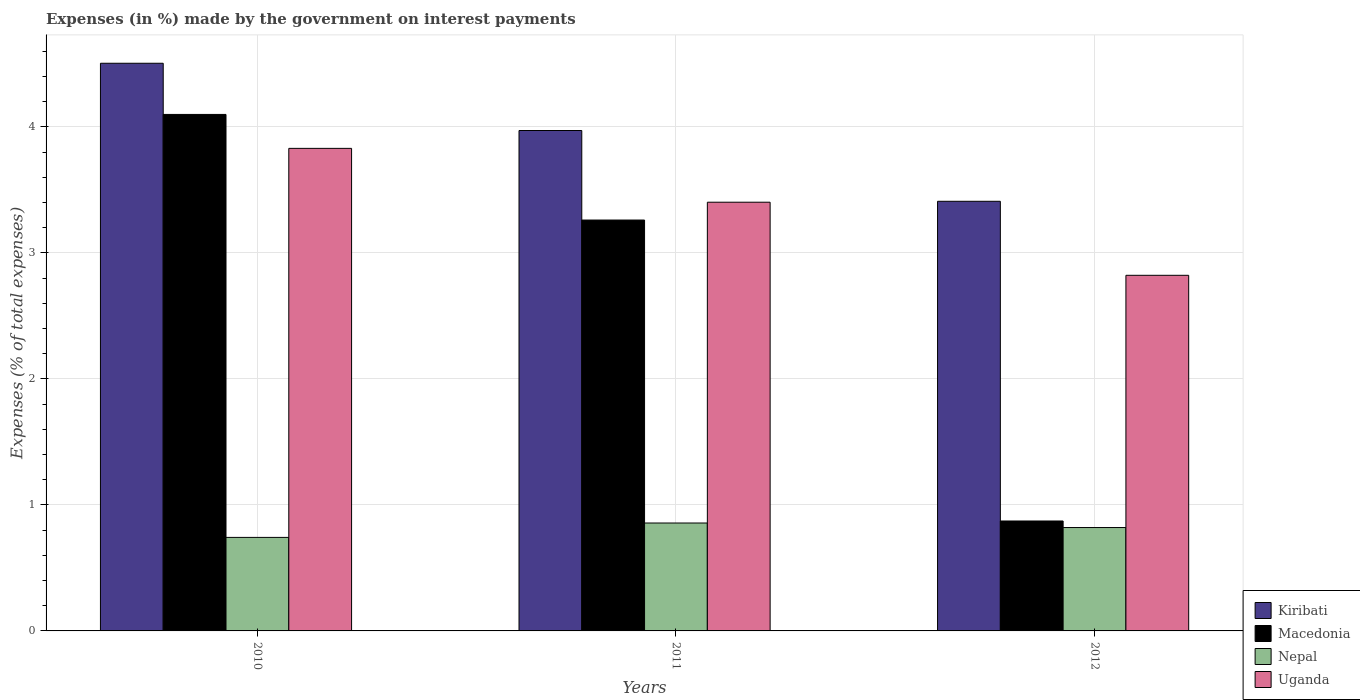How many groups of bars are there?
Offer a very short reply. 3. Are the number of bars per tick equal to the number of legend labels?
Your response must be concise. Yes. How many bars are there on the 1st tick from the left?
Make the answer very short. 4. What is the label of the 3rd group of bars from the left?
Keep it short and to the point. 2012. What is the percentage of expenses made by the government on interest payments in Uganda in 2011?
Ensure brevity in your answer.  3.4. Across all years, what is the maximum percentage of expenses made by the government on interest payments in Uganda?
Ensure brevity in your answer.  3.83. Across all years, what is the minimum percentage of expenses made by the government on interest payments in Macedonia?
Ensure brevity in your answer.  0.87. In which year was the percentage of expenses made by the government on interest payments in Uganda maximum?
Provide a short and direct response. 2010. What is the total percentage of expenses made by the government on interest payments in Nepal in the graph?
Your answer should be compact. 2.42. What is the difference between the percentage of expenses made by the government on interest payments in Kiribati in 2010 and that in 2012?
Offer a very short reply. 1.1. What is the difference between the percentage of expenses made by the government on interest payments in Uganda in 2011 and the percentage of expenses made by the government on interest payments in Nepal in 2010?
Provide a short and direct response. 2.66. What is the average percentage of expenses made by the government on interest payments in Macedonia per year?
Your response must be concise. 2.74. In the year 2011, what is the difference between the percentage of expenses made by the government on interest payments in Kiribati and percentage of expenses made by the government on interest payments in Macedonia?
Make the answer very short. 0.71. In how many years, is the percentage of expenses made by the government on interest payments in Kiribati greater than 3.2 %?
Provide a succinct answer. 3. What is the ratio of the percentage of expenses made by the government on interest payments in Kiribati in 2010 to that in 2012?
Give a very brief answer. 1.32. What is the difference between the highest and the second highest percentage of expenses made by the government on interest payments in Kiribati?
Your answer should be very brief. 0.53. What is the difference between the highest and the lowest percentage of expenses made by the government on interest payments in Macedonia?
Offer a very short reply. 3.23. What does the 4th bar from the left in 2011 represents?
Provide a short and direct response. Uganda. What does the 3rd bar from the right in 2012 represents?
Offer a very short reply. Macedonia. How many bars are there?
Provide a short and direct response. 12. What is the difference between two consecutive major ticks on the Y-axis?
Provide a short and direct response. 1. Are the values on the major ticks of Y-axis written in scientific E-notation?
Offer a very short reply. No. Where does the legend appear in the graph?
Provide a succinct answer. Bottom right. How are the legend labels stacked?
Keep it short and to the point. Vertical. What is the title of the graph?
Provide a succinct answer. Expenses (in %) made by the government on interest payments. What is the label or title of the X-axis?
Offer a very short reply. Years. What is the label or title of the Y-axis?
Give a very brief answer. Expenses (% of total expenses). What is the Expenses (% of total expenses) in Kiribati in 2010?
Give a very brief answer. 4.51. What is the Expenses (% of total expenses) of Macedonia in 2010?
Your answer should be compact. 4.1. What is the Expenses (% of total expenses) in Nepal in 2010?
Provide a short and direct response. 0.74. What is the Expenses (% of total expenses) in Uganda in 2010?
Your answer should be very brief. 3.83. What is the Expenses (% of total expenses) in Kiribati in 2011?
Provide a short and direct response. 3.97. What is the Expenses (% of total expenses) in Macedonia in 2011?
Keep it short and to the point. 3.26. What is the Expenses (% of total expenses) in Nepal in 2011?
Ensure brevity in your answer.  0.86. What is the Expenses (% of total expenses) in Uganda in 2011?
Your answer should be very brief. 3.4. What is the Expenses (% of total expenses) of Kiribati in 2012?
Keep it short and to the point. 3.41. What is the Expenses (% of total expenses) in Macedonia in 2012?
Your answer should be very brief. 0.87. What is the Expenses (% of total expenses) in Nepal in 2012?
Provide a succinct answer. 0.82. What is the Expenses (% of total expenses) of Uganda in 2012?
Give a very brief answer. 2.82. Across all years, what is the maximum Expenses (% of total expenses) in Kiribati?
Provide a succinct answer. 4.51. Across all years, what is the maximum Expenses (% of total expenses) in Macedonia?
Give a very brief answer. 4.1. Across all years, what is the maximum Expenses (% of total expenses) of Nepal?
Offer a terse response. 0.86. Across all years, what is the maximum Expenses (% of total expenses) in Uganda?
Make the answer very short. 3.83. Across all years, what is the minimum Expenses (% of total expenses) of Kiribati?
Make the answer very short. 3.41. Across all years, what is the minimum Expenses (% of total expenses) in Macedonia?
Offer a very short reply. 0.87. Across all years, what is the minimum Expenses (% of total expenses) in Nepal?
Your answer should be very brief. 0.74. Across all years, what is the minimum Expenses (% of total expenses) in Uganda?
Provide a short and direct response. 2.82. What is the total Expenses (% of total expenses) of Kiribati in the graph?
Ensure brevity in your answer.  11.89. What is the total Expenses (% of total expenses) in Macedonia in the graph?
Offer a very short reply. 8.23. What is the total Expenses (% of total expenses) in Nepal in the graph?
Keep it short and to the point. 2.42. What is the total Expenses (% of total expenses) in Uganda in the graph?
Your answer should be very brief. 10.05. What is the difference between the Expenses (% of total expenses) of Kiribati in 2010 and that in 2011?
Provide a succinct answer. 0.53. What is the difference between the Expenses (% of total expenses) of Macedonia in 2010 and that in 2011?
Your response must be concise. 0.84. What is the difference between the Expenses (% of total expenses) in Nepal in 2010 and that in 2011?
Provide a succinct answer. -0.11. What is the difference between the Expenses (% of total expenses) in Uganda in 2010 and that in 2011?
Your answer should be compact. 0.43. What is the difference between the Expenses (% of total expenses) of Kiribati in 2010 and that in 2012?
Provide a short and direct response. 1.1. What is the difference between the Expenses (% of total expenses) of Macedonia in 2010 and that in 2012?
Provide a short and direct response. 3.23. What is the difference between the Expenses (% of total expenses) of Nepal in 2010 and that in 2012?
Provide a succinct answer. -0.08. What is the difference between the Expenses (% of total expenses) of Uganda in 2010 and that in 2012?
Your answer should be very brief. 1.01. What is the difference between the Expenses (% of total expenses) of Kiribati in 2011 and that in 2012?
Your answer should be compact. 0.56. What is the difference between the Expenses (% of total expenses) of Macedonia in 2011 and that in 2012?
Offer a terse response. 2.39. What is the difference between the Expenses (% of total expenses) in Nepal in 2011 and that in 2012?
Provide a short and direct response. 0.04. What is the difference between the Expenses (% of total expenses) in Uganda in 2011 and that in 2012?
Give a very brief answer. 0.58. What is the difference between the Expenses (% of total expenses) of Kiribati in 2010 and the Expenses (% of total expenses) of Macedonia in 2011?
Your answer should be compact. 1.24. What is the difference between the Expenses (% of total expenses) of Kiribati in 2010 and the Expenses (% of total expenses) of Nepal in 2011?
Provide a succinct answer. 3.65. What is the difference between the Expenses (% of total expenses) in Kiribati in 2010 and the Expenses (% of total expenses) in Uganda in 2011?
Provide a short and direct response. 1.1. What is the difference between the Expenses (% of total expenses) of Macedonia in 2010 and the Expenses (% of total expenses) of Nepal in 2011?
Make the answer very short. 3.24. What is the difference between the Expenses (% of total expenses) of Macedonia in 2010 and the Expenses (% of total expenses) of Uganda in 2011?
Make the answer very short. 0.7. What is the difference between the Expenses (% of total expenses) in Nepal in 2010 and the Expenses (% of total expenses) in Uganda in 2011?
Your answer should be compact. -2.66. What is the difference between the Expenses (% of total expenses) of Kiribati in 2010 and the Expenses (% of total expenses) of Macedonia in 2012?
Keep it short and to the point. 3.63. What is the difference between the Expenses (% of total expenses) of Kiribati in 2010 and the Expenses (% of total expenses) of Nepal in 2012?
Give a very brief answer. 3.68. What is the difference between the Expenses (% of total expenses) of Kiribati in 2010 and the Expenses (% of total expenses) of Uganda in 2012?
Ensure brevity in your answer.  1.68. What is the difference between the Expenses (% of total expenses) of Macedonia in 2010 and the Expenses (% of total expenses) of Nepal in 2012?
Keep it short and to the point. 3.28. What is the difference between the Expenses (% of total expenses) in Macedonia in 2010 and the Expenses (% of total expenses) in Uganda in 2012?
Provide a short and direct response. 1.28. What is the difference between the Expenses (% of total expenses) in Nepal in 2010 and the Expenses (% of total expenses) in Uganda in 2012?
Ensure brevity in your answer.  -2.08. What is the difference between the Expenses (% of total expenses) of Kiribati in 2011 and the Expenses (% of total expenses) of Macedonia in 2012?
Offer a terse response. 3.1. What is the difference between the Expenses (% of total expenses) in Kiribati in 2011 and the Expenses (% of total expenses) in Nepal in 2012?
Your answer should be compact. 3.15. What is the difference between the Expenses (% of total expenses) in Kiribati in 2011 and the Expenses (% of total expenses) in Uganda in 2012?
Your response must be concise. 1.15. What is the difference between the Expenses (% of total expenses) in Macedonia in 2011 and the Expenses (% of total expenses) in Nepal in 2012?
Give a very brief answer. 2.44. What is the difference between the Expenses (% of total expenses) of Macedonia in 2011 and the Expenses (% of total expenses) of Uganda in 2012?
Offer a terse response. 0.44. What is the difference between the Expenses (% of total expenses) of Nepal in 2011 and the Expenses (% of total expenses) of Uganda in 2012?
Provide a succinct answer. -1.97. What is the average Expenses (% of total expenses) in Kiribati per year?
Make the answer very short. 3.96. What is the average Expenses (% of total expenses) of Macedonia per year?
Ensure brevity in your answer.  2.74. What is the average Expenses (% of total expenses) of Nepal per year?
Your answer should be very brief. 0.81. What is the average Expenses (% of total expenses) of Uganda per year?
Your response must be concise. 3.35. In the year 2010, what is the difference between the Expenses (% of total expenses) of Kiribati and Expenses (% of total expenses) of Macedonia?
Ensure brevity in your answer.  0.41. In the year 2010, what is the difference between the Expenses (% of total expenses) of Kiribati and Expenses (% of total expenses) of Nepal?
Your response must be concise. 3.76. In the year 2010, what is the difference between the Expenses (% of total expenses) in Kiribati and Expenses (% of total expenses) in Uganda?
Your answer should be compact. 0.68. In the year 2010, what is the difference between the Expenses (% of total expenses) of Macedonia and Expenses (% of total expenses) of Nepal?
Give a very brief answer. 3.36. In the year 2010, what is the difference between the Expenses (% of total expenses) in Macedonia and Expenses (% of total expenses) in Uganda?
Your answer should be very brief. 0.27. In the year 2010, what is the difference between the Expenses (% of total expenses) of Nepal and Expenses (% of total expenses) of Uganda?
Give a very brief answer. -3.09. In the year 2011, what is the difference between the Expenses (% of total expenses) in Kiribati and Expenses (% of total expenses) in Macedonia?
Give a very brief answer. 0.71. In the year 2011, what is the difference between the Expenses (% of total expenses) of Kiribati and Expenses (% of total expenses) of Nepal?
Ensure brevity in your answer.  3.12. In the year 2011, what is the difference between the Expenses (% of total expenses) of Kiribati and Expenses (% of total expenses) of Uganda?
Offer a terse response. 0.57. In the year 2011, what is the difference between the Expenses (% of total expenses) of Macedonia and Expenses (% of total expenses) of Nepal?
Your answer should be very brief. 2.4. In the year 2011, what is the difference between the Expenses (% of total expenses) of Macedonia and Expenses (% of total expenses) of Uganda?
Make the answer very short. -0.14. In the year 2011, what is the difference between the Expenses (% of total expenses) of Nepal and Expenses (% of total expenses) of Uganda?
Keep it short and to the point. -2.55. In the year 2012, what is the difference between the Expenses (% of total expenses) in Kiribati and Expenses (% of total expenses) in Macedonia?
Ensure brevity in your answer.  2.54. In the year 2012, what is the difference between the Expenses (% of total expenses) in Kiribati and Expenses (% of total expenses) in Nepal?
Your response must be concise. 2.59. In the year 2012, what is the difference between the Expenses (% of total expenses) of Kiribati and Expenses (% of total expenses) of Uganda?
Offer a very short reply. 0.59. In the year 2012, what is the difference between the Expenses (% of total expenses) in Macedonia and Expenses (% of total expenses) in Nepal?
Your answer should be compact. 0.05. In the year 2012, what is the difference between the Expenses (% of total expenses) in Macedonia and Expenses (% of total expenses) in Uganda?
Your answer should be compact. -1.95. In the year 2012, what is the difference between the Expenses (% of total expenses) in Nepal and Expenses (% of total expenses) in Uganda?
Offer a terse response. -2. What is the ratio of the Expenses (% of total expenses) of Kiribati in 2010 to that in 2011?
Keep it short and to the point. 1.13. What is the ratio of the Expenses (% of total expenses) of Macedonia in 2010 to that in 2011?
Your response must be concise. 1.26. What is the ratio of the Expenses (% of total expenses) of Nepal in 2010 to that in 2011?
Your answer should be very brief. 0.87. What is the ratio of the Expenses (% of total expenses) in Uganda in 2010 to that in 2011?
Your answer should be very brief. 1.13. What is the ratio of the Expenses (% of total expenses) in Kiribati in 2010 to that in 2012?
Your response must be concise. 1.32. What is the ratio of the Expenses (% of total expenses) in Macedonia in 2010 to that in 2012?
Your answer should be very brief. 4.7. What is the ratio of the Expenses (% of total expenses) of Nepal in 2010 to that in 2012?
Provide a short and direct response. 0.9. What is the ratio of the Expenses (% of total expenses) in Uganda in 2010 to that in 2012?
Your response must be concise. 1.36. What is the ratio of the Expenses (% of total expenses) in Kiribati in 2011 to that in 2012?
Offer a very short reply. 1.16. What is the ratio of the Expenses (% of total expenses) in Macedonia in 2011 to that in 2012?
Offer a terse response. 3.74. What is the ratio of the Expenses (% of total expenses) of Nepal in 2011 to that in 2012?
Make the answer very short. 1.04. What is the ratio of the Expenses (% of total expenses) in Uganda in 2011 to that in 2012?
Offer a terse response. 1.21. What is the difference between the highest and the second highest Expenses (% of total expenses) in Kiribati?
Your answer should be compact. 0.53. What is the difference between the highest and the second highest Expenses (% of total expenses) in Macedonia?
Make the answer very short. 0.84. What is the difference between the highest and the second highest Expenses (% of total expenses) in Nepal?
Keep it short and to the point. 0.04. What is the difference between the highest and the second highest Expenses (% of total expenses) in Uganda?
Your answer should be very brief. 0.43. What is the difference between the highest and the lowest Expenses (% of total expenses) of Kiribati?
Make the answer very short. 1.1. What is the difference between the highest and the lowest Expenses (% of total expenses) in Macedonia?
Make the answer very short. 3.23. What is the difference between the highest and the lowest Expenses (% of total expenses) of Nepal?
Your answer should be very brief. 0.11. What is the difference between the highest and the lowest Expenses (% of total expenses) in Uganda?
Keep it short and to the point. 1.01. 